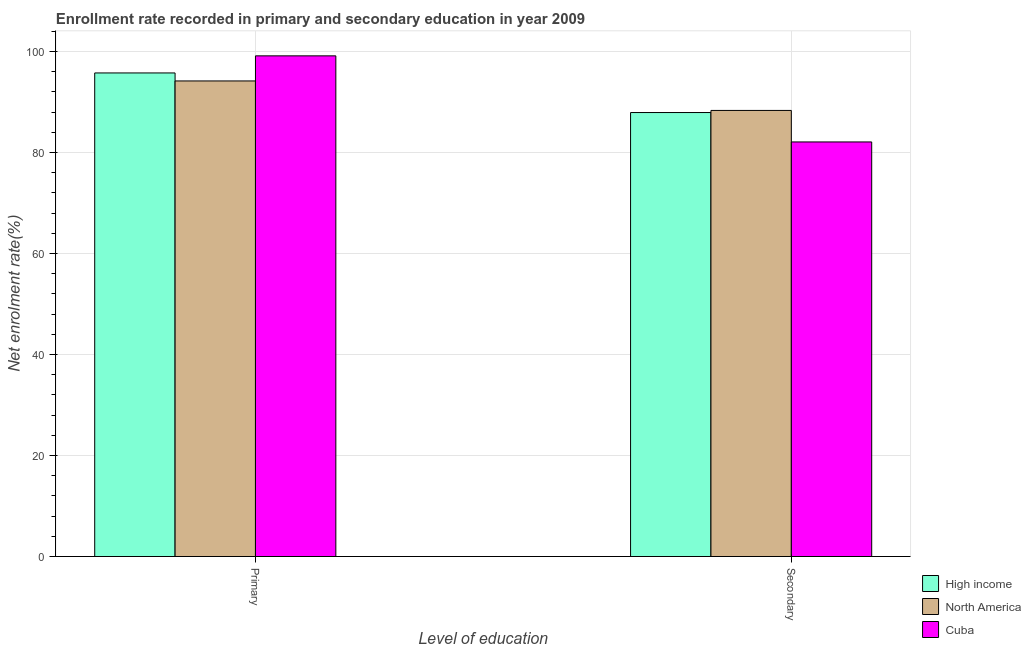How many different coloured bars are there?
Ensure brevity in your answer.  3. How many groups of bars are there?
Offer a very short reply. 2. Are the number of bars per tick equal to the number of legend labels?
Provide a succinct answer. Yes. What is the label of the 1st group of bars from the left?
Provide a short and direct response. Primary. What is the enrollment rate in secondary education in North America?
Provide a short and direct response. 88.32. Across all countries, what is the maximum enrollment rate in primary education?
Your answer should be compact. 99.13. Across all countries, what is the minimum enrollment rate in secondary education?
Your answer should be very brief. 82.08. In which country was the enrollment rate in primary education maximum?
Provide a short and direct response. Cuba. In which country was the enrollment rate in secondary education minimum?
Offer a very short reply. Cuba. What is the total enrollment rate in primary education in the graph?
Provide a succinct answer. 289.03. What is the difference between the enrollment rate in secondary education in North America and that in Cuba?
Offer a very short reply. 6.24. What is the difference between the enrollment rate in primary education in High income and the enrollment rate in secondary education in Cuba?
Provide a succinct answer. 13.66. What is the average enrollment rate in primary education per country?
Your response must be concise. 96.34. What is the difference between the enrollment rate in primary education and enrollment rate in secondary education in Cuba?
Your response must be concise. 17.04. In how many countries, is the enrollment rate in primary education greater than 56 %?
Ensure brevity in your answer.  3. What is the ratio of the enrollment rate in primary education in North America to that in High income?
Keep it short and to the point. 0.98. In how many countries, is the enrollment rate in secondary education greater than the average enrollment rate in secondary education taken over all countries?
Ensure brevity in your answer.  2. What does the 2nd bar from the right in Secondary represents?
Your answer should be very brief. North America. How many bars are there?
Offer a terse response. 6. Does the graph contain grids?
Give a very brief answer. Yes. How are the legend labels stacked?
Keep it short and to the point. Vertical. What is the title of the graph?
Your answer should be compact. Enrollment rate recorded in primary and secondary education in year 2009. Does "Faeroe Islands" appear as one of the legend labels in the graph?
Offer a very short reply. No. What is the label or title of the X-axis?
Your answer should be compact. Level of education. What is the label or title of the Y-axis?
Give a very brief answer. Net enrolment rate(%). What is the Net enrolment rate(%) in High income in Primary?
Your response must be concise. 95.74. What is the Net enrolment rate(%) of North America in Primary?
Provide a short and direct response. 94.16. What is the Net enrolment rate(%) in Cuba in Primary?
Keep it short and to the point. 99.13. What is the Net enrolment rate(%) in High income in Secondary?
Make the answer very short. 87.9. What is the Net enrolment rate(%) in North America in Secondary?
Offer a terse response. 88.32. What is the Net enrolment rate(%) of Cuba in Secondary?
Ensure brevity in your answer.  82.08. Across all Level of education, what is the maximum Net enrolment rate(%) of High income?
Offer a terse response. 95.74. Across all Level of education, what is the maximum Net enrolment rate(%) in North America?
Offer a very short reply. 94.16. Across all Level of education, what is the maximum Net enrolment rate(%) of Cuba?
Ensure brevity in your answer.  99.13. Across all Level of education, what is the minimum Net enrolment rate(%) of High income?
Ensure brevity in your answer.  87.9. Across all Level of education, what is the minimum Net enrolment rate(%) in North America?
Offer a terse response. 88.32. Across all Level of education, what is the minimum Net enrolment rate(%) of Cuba?
Your answer should be compact. 82.08. What is the total Net enrolment rate(%) of High income in the graph?
Make the answer very short. 183.65. What is the total Net enrolment rate(%) of North America in the graph?
Your response must be concise. 182.48. What is the total Net enrolment rate(%) of Cuba in the graph?
Provide a short and direct response. 181.21. What is the difference between the Net enrolment rate(%) in High income in Primary and that in Secondary?
Offer a very short reply. 7.84. What is the difference between the Net enrolment rate(%) in North America in Primary and that in Secondary?
Offer a terse response. 5.84. What is the difference between the Net enrolment rate(%) in Cuba in Primary and that in Secondary?
Offer a terse response. 17.04. What is the difference between the Net enrolment rate(%) of High income in Primary and the Net enrolment rate(%) of North America in Secondary?
Offer a very short reply. 7.42. What is the difference between the Net enrolment rate(%) of High income in Primary and the Net enrolment rate(%) of Cuba in Secondary?
Keep it short and to the point. 13.66. What is the difference between the Net enrolment rate(%) of North America in Primary and the Net enrolment rate(%) of Cuba in Secondary?
Offer a very short reply. 12.08. What is the average Net enrolment rate(%) in High income per Level of education?
Provide a short and direct response. 91.82. What is the average Net enrolment rate(%) in North America per Level of education?
Your response must be concise. 91.24. What is the average Net enrolment rate(%) of Cuba per Level of education?
Give a very brief answer. 90.6. What is the difference between the Net enrolment rate(%) of High income and Net enrolment rate(%) of North America in Primary?
Your response must be concise. 1.58. What is the difference between the Net enrolment rate(%) of High income and Net enrolment rate(%) of Cuba in Primary?
Offer a terse response. -3.38. What is the difference between the Net enrolment rate(%) in North America and Net enrolment rate(%) in Cuba in Primary?
Your answer should be compact. -4.97. What is the difference between the Net enrolment rate(%) in High income and Net enrolment rate(%) in North America in Secondary?
Your answer should be compact. -0.42. What is the difference between the Net enrolment rate(%) of High income and Net enrolment rate(%) of Cuba in Secondary?
Offer a terse response. 5.82. What is the difference between the Net enrolment rate(%) in North America and Net enrolment rate(%) in Cuba in Secondary?
Your response must be concise. 6.24. What is the ratio of the Net enrolment rate(%) of High income in Primary to that in Secondary?
Your response must be concise. 1.09. What is the ratio of the Net enrolment rate(%) in North America in Primary to that in Secondary?
Your response must be concise. 1.07. What is the ratio of the Net enrolment rate(%) of Cuba in Primary to that in Secondary?
Provide a short and direct response. 1.21. What is the difference between the highest and the second highest Net enrolment rate(%) in High income?
Your answer should be compact. 7.84. What is the difference between the highest and the second highest Net enrolment rate(%) of North America?
Your response must be concise. 5.84. What is the difference between the highest and the second highest Net enrolment rate(%) in Cuba?
Provide a succinct answer. 17.04. What is the difference between the highest and the lowest Net enrolment rate(%) of High income?
Provide a succinct answer. 7.84. What is the difference between the highest and the lowest Net enrolment rate(%) of North America?
Keep it short and to the point. 5.84. What is the difference between the highest and the lowest Net enrolment rate(%) in Cuba?
Offer a very short reply. 17.04. 